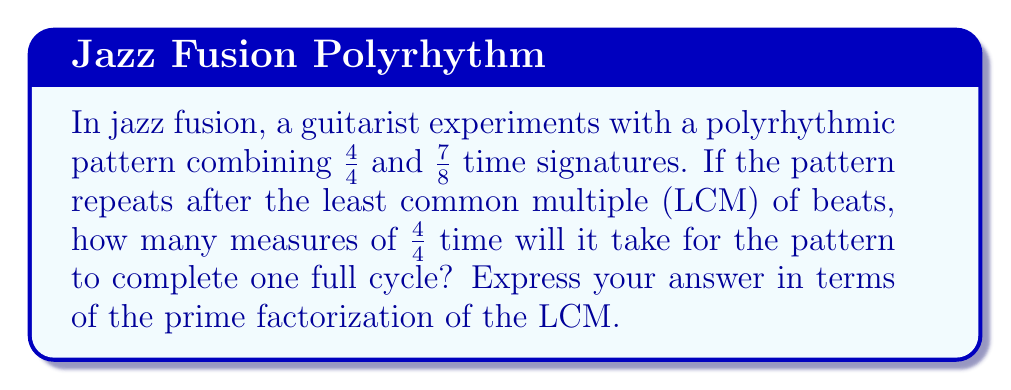Give your solution to this math problem. Let's approach this step-by-step:

1) First, we need to find the LCM of 4 and 7:
   
   $4 = 2^2$
   $7 = 7$

   $LCM(4,7) = 2^2 \times 7 = 28$

2) This means the pattern will repeat after 28 beats.

3) Now, we need to determine how many measures of 4/4 time this represents:

   $\frac{28 \text{ beats}}{4 \text{ beats per measure}} = 7 \text{ measures}$

4) The prime factorization of 28 is $2^2 \times 7$

5) Therefore, the number of measures can be expressed as:

   $\frac{2^2 \times 7}{2^2} = 7$

This matches our calculation in step 3.
Answer: $7 = 7$ 